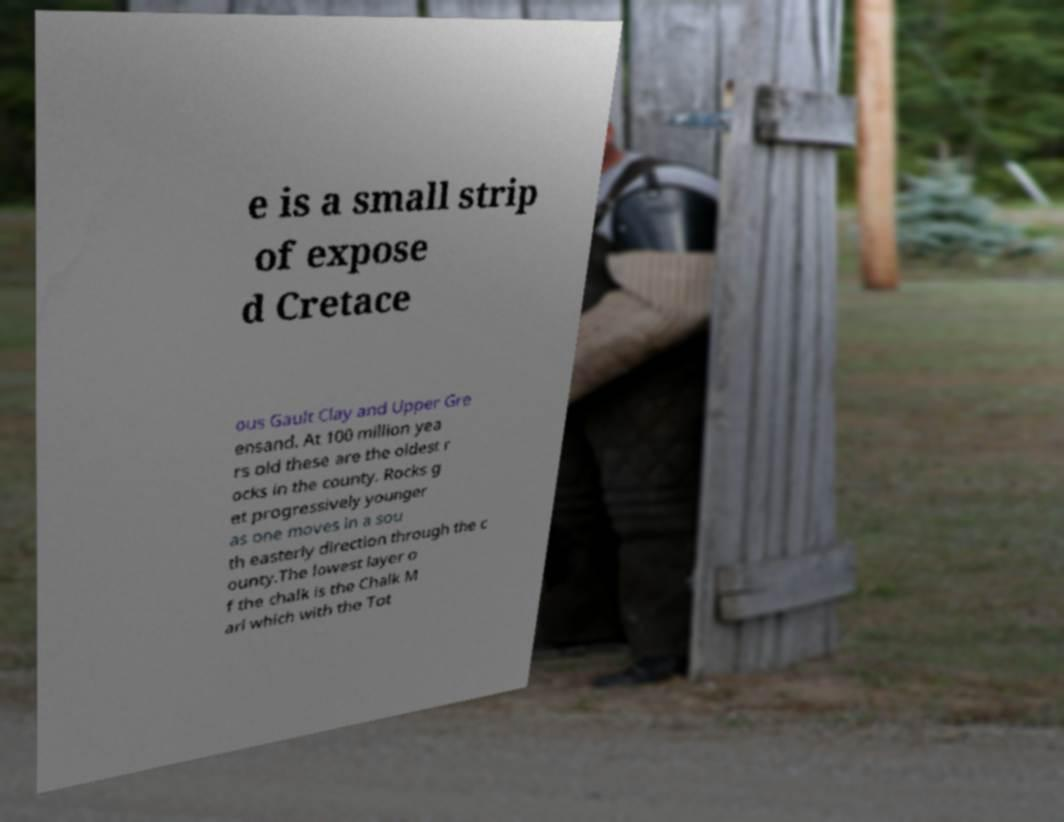Please read and relay the text visible in this image. What does it say? e is a small strip of expose d Cretace ous Gault Clay and Upper Gre ensand. At 100 million yea rs old these are the oldest r ocks in the county. Rocks g et progressively younger as one moves in a sou th easterly direction through the c ounty.The lowest layer o f the chalk is the Chalk M arl which with the Tot 